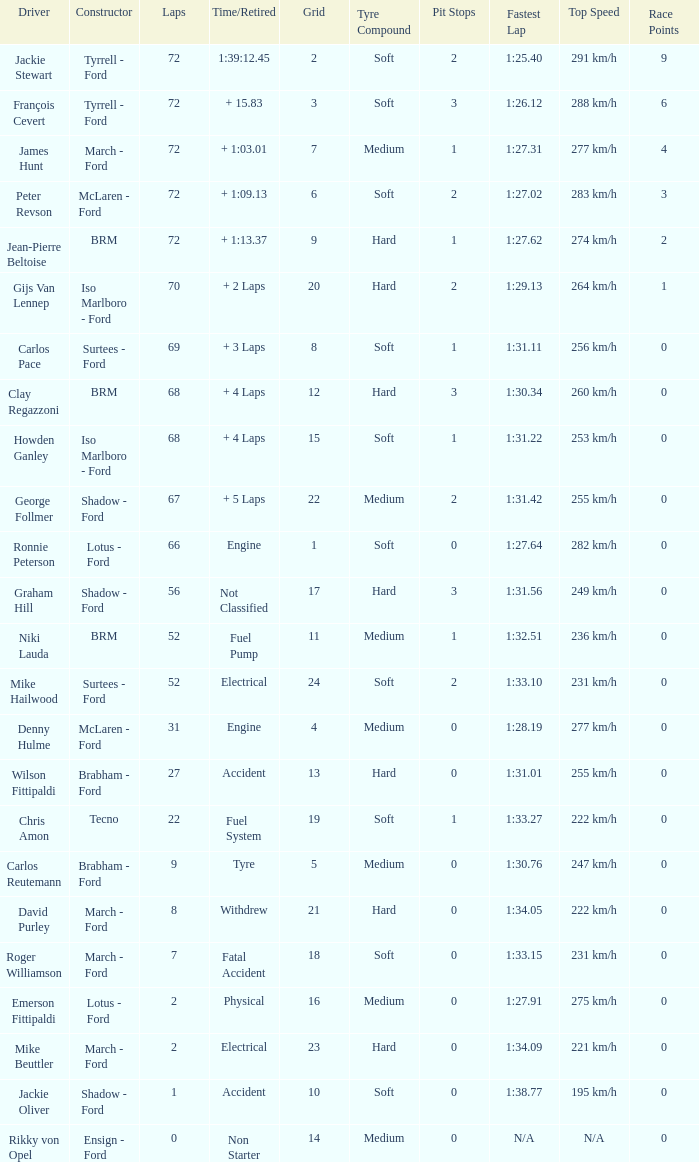What is the top grid that roger williamson lapped less than 7? None. 